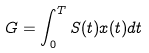<formula> <loc_0><loc_0><loc_500><loc_500>G = \int _ { 0 } ^ { T } S ( t ) x ( t ) d t</formula> 